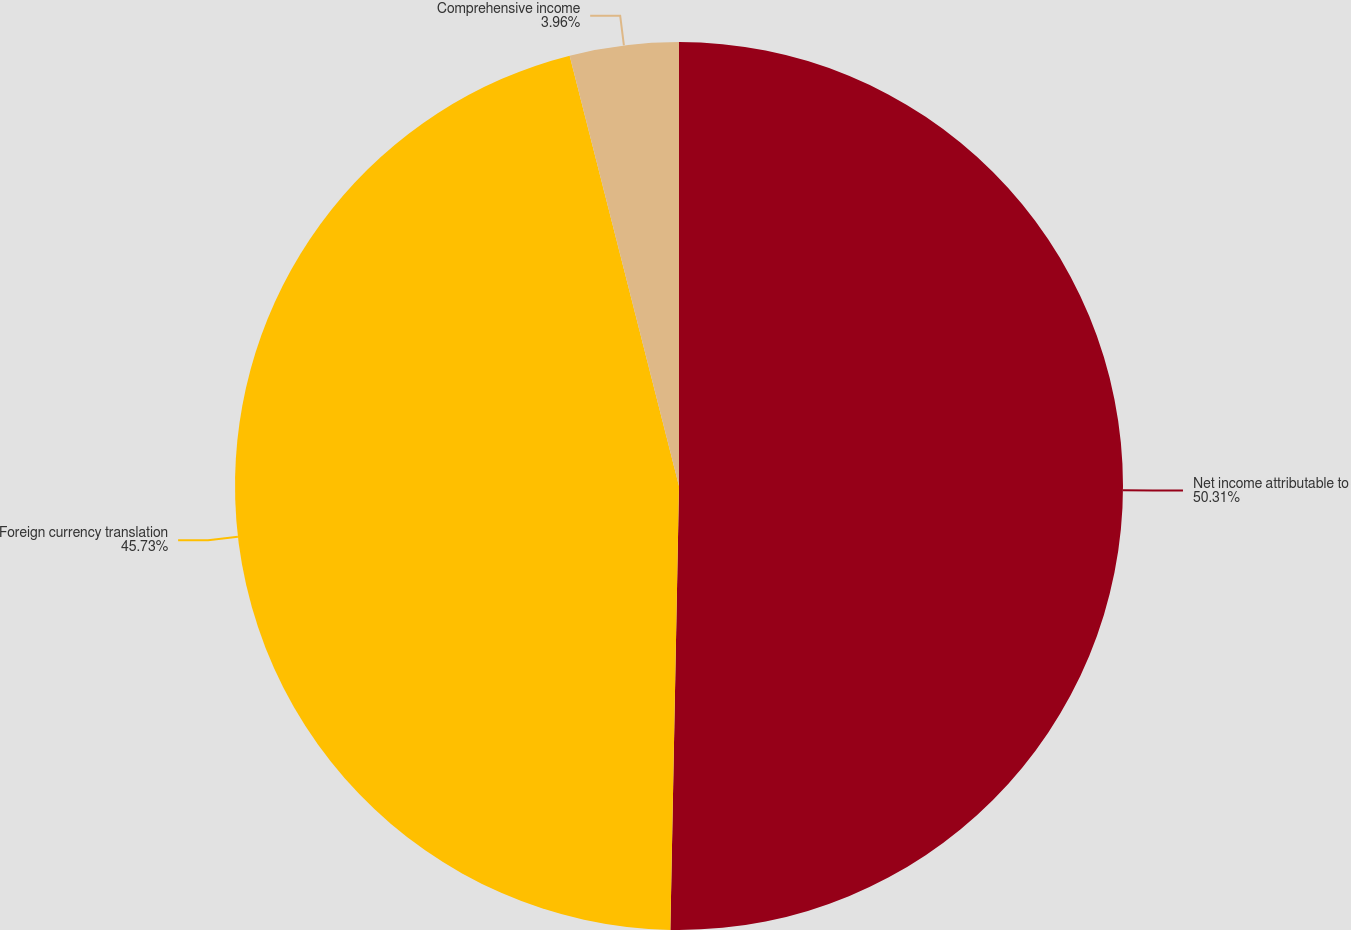Convert chart. <chart><loc_0><loc_0><loc_500><loc_500><pie_chart><fcel>Net income attributable to<fcel>Foreign currency translation<fcel>Comprehensive income<nl><fcel>50.31%<fcel>45.73%<fcel>3.96%<nl></chart> 